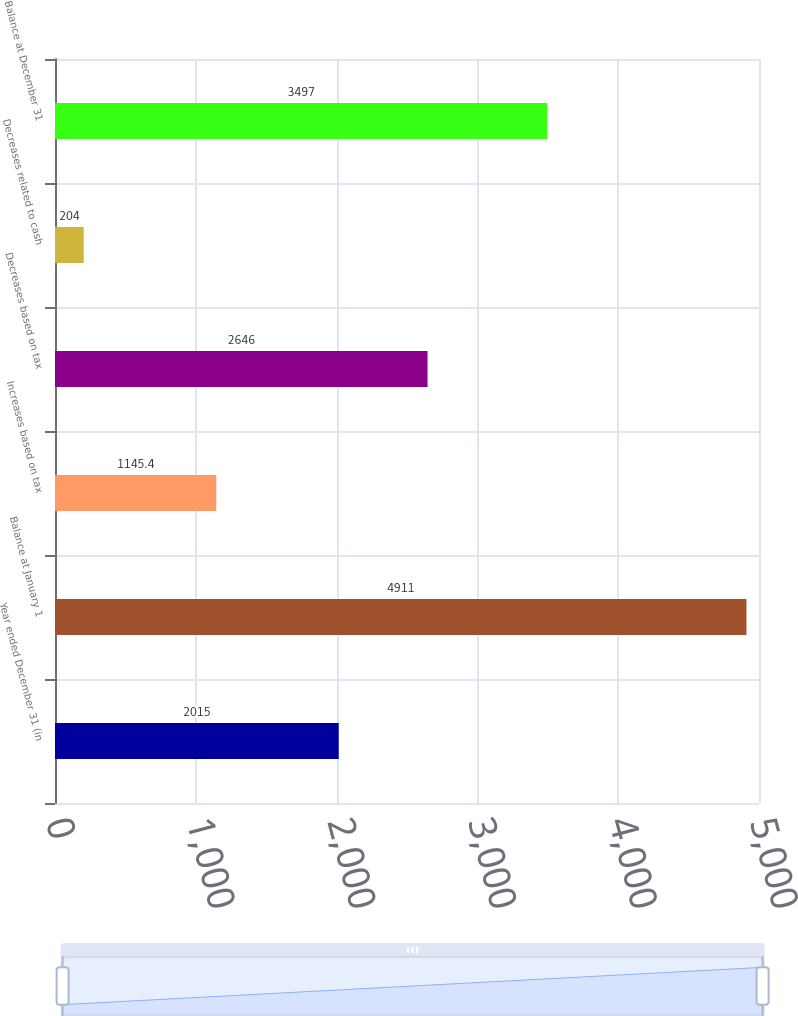Convert chart to OTSL. <chart><loc_0><loc_0><loc_500><loc_500><bar_chart><fcel>Year ended December 31 (in<fcel>Balance at January 1<fcel>Increases based on tax<fcel>Decreases based on tax<fcel>Decreases related to cash<fcel>Balance at December 31<nl><fcel>2015<fcel>4911<fcel>1145.4<fcel>2646<fcel>204<fcel>3497<nl></chart> 